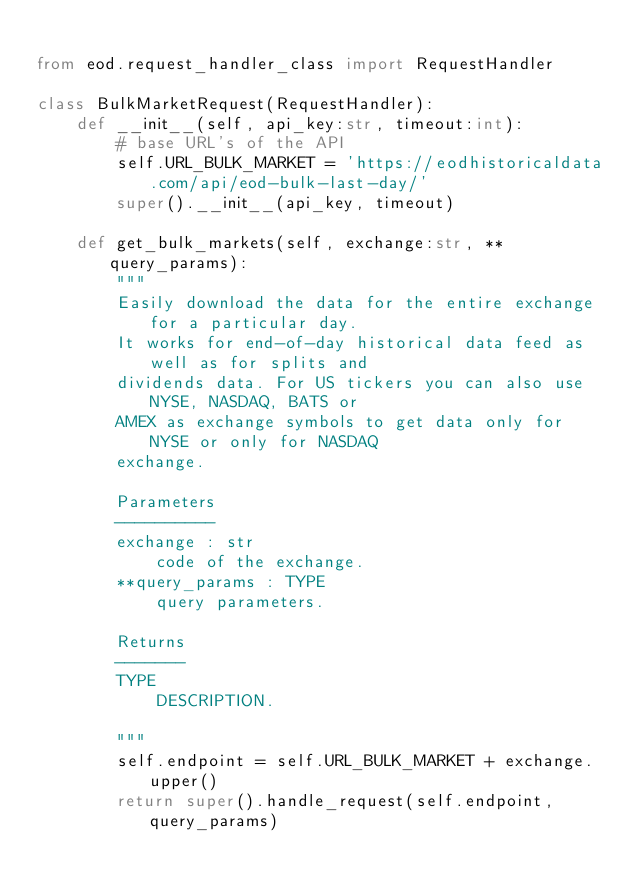<code> <loc_0><loc_0><loc_500><loc_500><_Python_>
from eod.request_handler_class import RequestHandler

class BulkMarketRequest(RequestHandler):
    def __init__(self, api_key:str, timeout:int):
        # base URL's of the API
        self.URL_BULK_MARKET = 'https://eodhistoricaldata.com/api/eod-bulk-last-day/'
        super().__init__(api_key, timeout)
    
    def get_bulk_markets(self, exchange:str, **query_params):
        """
        Easily download the data for the entire exchange for a particular day.
        It works for end-of-day historical data feed as well as for splits and
        dividends data. For US tickers you can also use NYSE, NASDAQ, BATS or 
        AMEX as exchange symbols to get data only for NYSE or only for NASDAQ 
        exchange.

        Parameters
        ----------
        exchange : str
            code of the exchange.
        **query_params : TYPE
            query parameters.

        Returns
        -------
        TYPE
            DESCRIPTION.

        """
        self.endpoint = self.URL_BULK_MARKET + exchange.upper()
        return super().handle_request(self.endpoint, query_params)</code> 